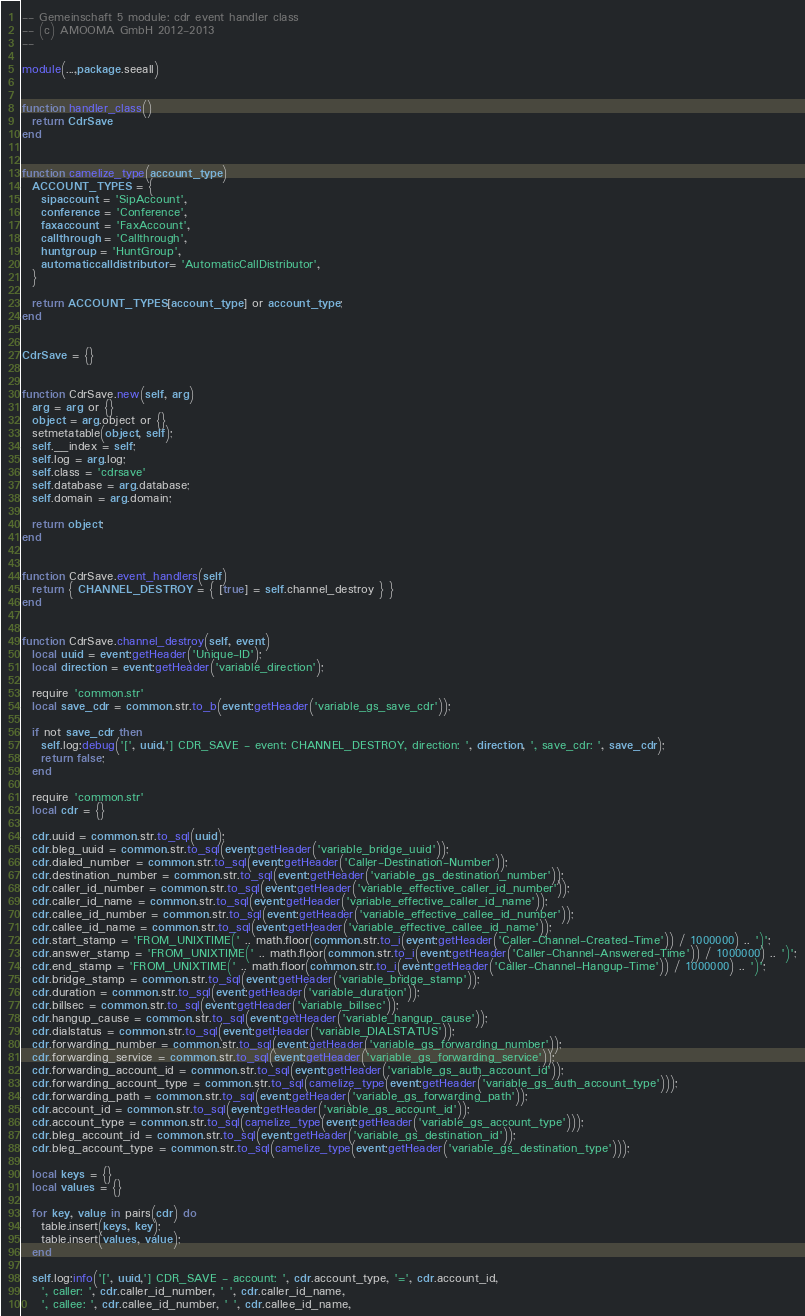<code> <loc_0><loc_0><loc_500><loc_500><_Lua_>-- Gemeinschaft 5 module: cdr event handler class
-- (c) AMOOMA GmbH 2012-2013
-- 

module(...,package.seeall)


function handler_class()
  return CdrSave
end


function camelize_type(account_type)
  ACCOUNT_TYPES = {
    sipaccount = 'SipAccount',
    conference = 'Conference', 
    faxaccount = 'FaxAccount', 
    callthrough = 'Callthrough', 
    huntgroup = 'HuntGroup', 
    automaticcalldistributor = 'AutomaticCallDistributor',
  }

  return ACCOUNT_TYPES[account_type] or account_type;
end


CdrSave = {}


function CdrSave.new(self, arg)
  arg = arg or {}
  object = arg.object or {}
  setmetatable(object, self);
  self.__index = self;
  self.log = arg.log;
  self.class = 'cdrsave'
  self.database = arg.database;
  self.domain = arg.domain;

  return object;
end


function CdrSave.event_handlers(self)
  return { CHANNEL_DESTROY = { [true] = self.channel_destroy } }
end


function CdrSave.channel_destroy(self, event)
  local uuid = event:getHeader('Unique-ID');
  local direction = event:getHeader('variable_direction');

  require 'common.str'
  local save_cdr = common.str.to_b(event:getHeader('variable_gs_save_cdr'));

  if not save_cdr then
    self.log:debug('[', uuid,'] CDR_SAVE - event: CHANNEL_DESTROY, direction: ', direction, ', save_cdr: ', save_cdr);
    return false;
  end
  
  require 'common.str'
  local cdr = {}

  cdr.uuid = common.str.to_sql(uuid);
  cdr.bleg_uuid = common.str.to_sql(event:getHeader('variable_bridge_uuid'));
  cdr.dialed_number = common.str.to_sql(event:getHeader('Caller-Destination-Number'));
  cdr.destination_number = common.str.to_sql(event:getHeader('variable_gs_destination_number'));
  cdr.caller_id_number = common.str.to_sql(event:getHeader('variable_effective_caller_id_number'));
  cdr.caller_id_name = common.str.to_sql(event:getHeader('variable_effective_caller_id_name'));
  cdr.callee_id_number = common.str.to_sql(event:getHeader('variable_effective_callee_id_number'));
  cdr.callee_id_name = common.str.to_sql(event:getHeader('variable_effective_callee_id_name'));
  cdr.start_stamp = 'FROM_UNIXTIME(' .. math.floor(common.str.to_i(event:getHeader('Caller-Channel-Created-Time')) / 1000000) .. ')';
  cdr.answer_stamp = 'FROM_UNIXTIME(' .. math.floor(common.str.to_i(event:getHeader('Caller-Channel-Answered-Time')) / 1000000) .. ')';
  cdr.end_stamp = 'FROM_UNIXTIME(' .. math.floor(common.str.to_i(event:getHeader('Caller-Channel-Hangup-Time')) / 1000000) .. ')';
  cdr.bridge_stamp = common.str.to_sql(event:getHeader('variable_bridge_stamp'));
  cdr.duration = common.str.to_sql(event:getHeader('variable_duration'));
  cdr.billsec = common.str.to_sql(event:getHeader('variable_billsec'));
  cdr.hangup_cause = common.str.to_sql(event:getHeader('variable_hangup_cause'));
  cdr.dialstatus = common.str.to_sql(event:getHeader('variable_DIALSTATUS'));
  cdr.forwarding_number = common.str.to_sql(event:getHeader('variable_gs_forwarding_number'));
  cdr.forwarding_service = common.str.to_sql(event:getHeader('variable_gs_forwarding_service'));
  cdr.forwarding_account_id = common.str.to_sql(event:getHeader('variable_gs_auth_account_id'));
  cdr.forwarding_account_type = common.str.to_sql(camelize_type(event:getHeader('variable_gs_auth_account_type')));
  cdr.forwarding_path = common.str.to_sql(event:getHeader('variable_gs_forwarding_path'));
  cdr.account_id = common.str.to_sql(event:getHeader('variable_gs_account_id'));
  cdr.account_type = common.str.to_sql(camelize_type(event:getHeader('variable_gs_account_type')));
  cdr.bleg_account_id = common.str.to_sql(event:getHeader('variable_gs_destination_id'));
  cdr.bleg_account_type = common.str.to_sql(camelize_type(event:getHeader('variable_gs_destination_type')));
  
  local keys = {}
  local values = {}

  for key, value in pairs(cdr) do
    table.insert(keys, key);
    table.insert(values, value);
  end

  self.log:info('[', uuid,'] CDR_SAVE - account: ', cdr.account_type, '=', cdr.account_id, 
    ', caller: ', cdr.caller_id_number, ' ', cdr.caller_id_name,
    ', callee: ', cdr.callee_id_number, ' ', cdr.callee_id_name,</code> 